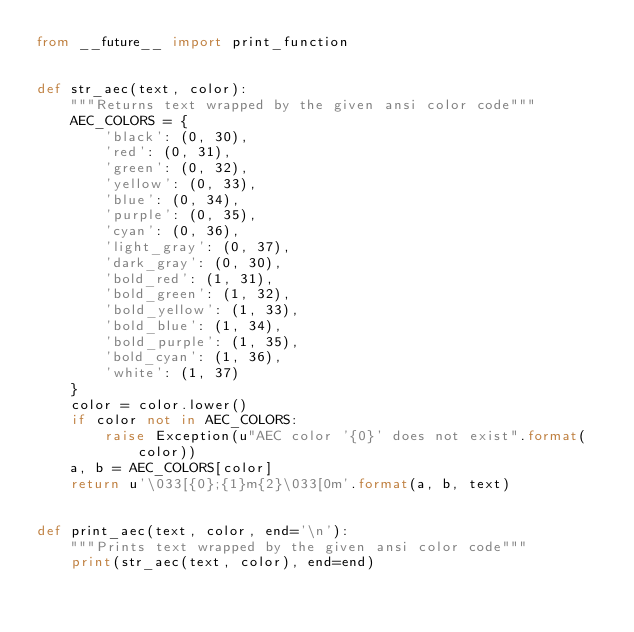Convert code to text. <code><loc_0><loc_0><loc_500><loc_500><_Python_>from __future__ import print_function


def str_aec(text, color):
    """Returns text wrapped by the given ansi color code"""
    AEC_COLORS = {
        'black': (0, 30),
        'red': (0, 31),
        'green': (0, 32),
        'yellow': (0, 33),
        'blue': (0, 34),
        'purple': (0, 35),
        'cyan': (0, 36),
        'light_gray': (0, 37),
        'dark_gray': (0, 30),
        'bold_red': (1, 31),
        'bold_green': (1, 32),
        'bold_yellow': (1, 33),
        'bold_blue': (1, 34),
        'bold_purple': (1, 35),
        'bold_cyan': (1, 36),
        'white': (1, 37)
    }
    color = color.lower()
    if color not in AEC_COLORS:
        raise Exception(u"AEC color '{0}' does not exist".format(color))
    a, b = AEC_COLORS[color]
    return u'\033[{0};{1}m{2}\033[0m'.format(a, b, text)


def print_aec(text, color, end='\n'):
    """Prints text wrapped by the given ansi color code"""
    print(str_aec(text, color), end=end)
</code> 